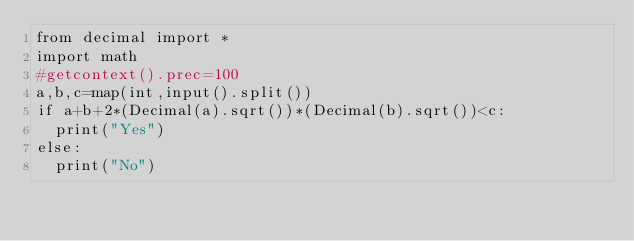<code> <loc_0><loc_0><loc_500><loc_500><_Python_>from decimal import *
import math
#getcontext().prec=100
a,b,c=map(int,input().split())
if a+b+2*(Decimal(a).sqrt())*(Decimal(b).sqrt())<c:
  print("Yes")
else:
  print("No")
</code> 